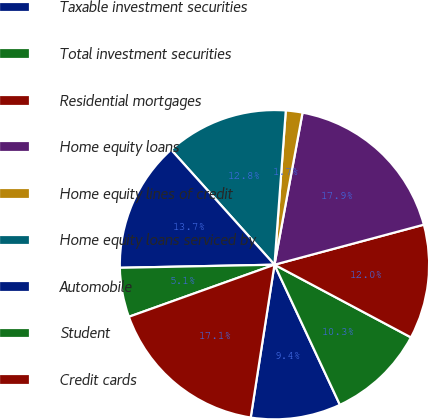<chart> <loc_0><loc_0><loc_500><loc_500><pie_chart><fcel>Taxable investment securities<fcel>Total investment securities<fcel>Residential mortgages<fcel>Home equity loans<fcel>Home equity lines of credit<fcel>Home equity loans serviced by<fcel>Automobile<fcel>Student<fcel>Credit cards<nl><fcel>9.41%<fcel>10.26%<fcel>11.96%<fcel>17.93%<fcel>1.74%<fcel>12.82%<fcel>13.67%<fcel>5.15%<fcel>17.08%<nl></chart> 